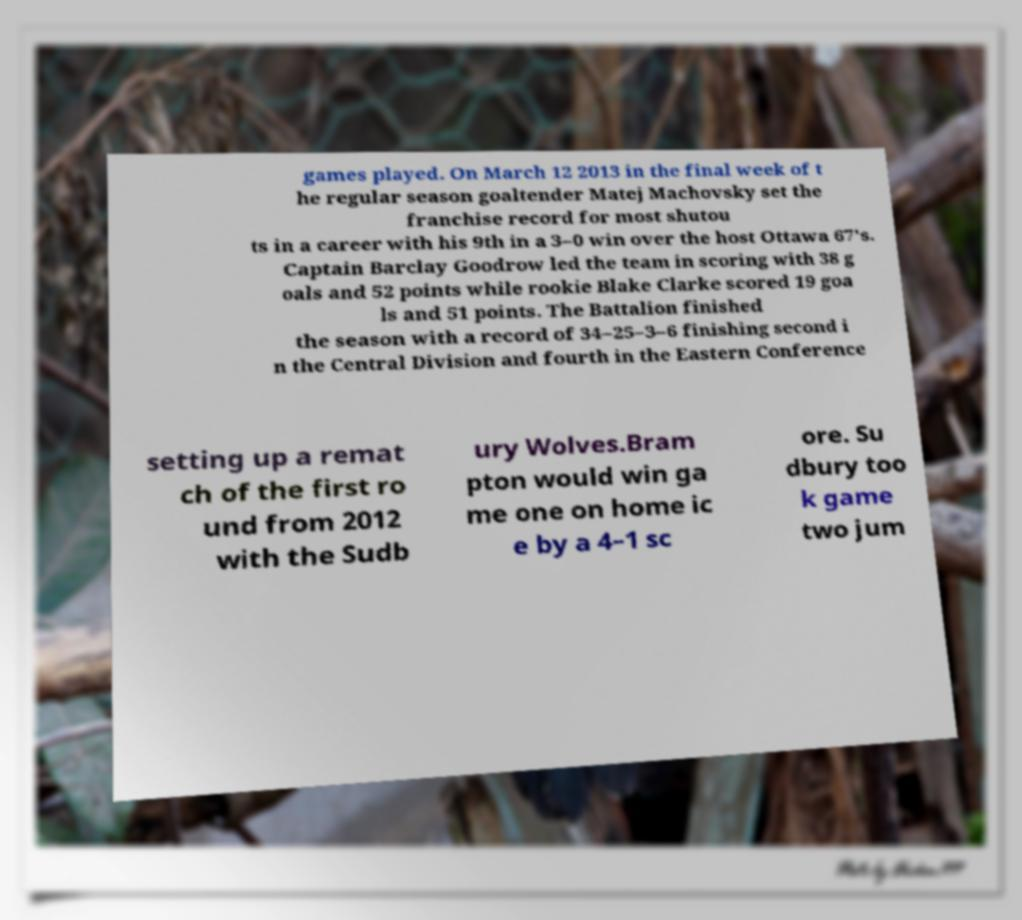Please identify and transcribe the text found in this image. games played. On March 12 2013 in the final week of t he regular season goaltender Matej Machovsky set the franchise record for most shutou ts in a career with his 9th in a 3–0 win over the host Ottawa 67's. Captain Barclay Goodrow led the team in scoring with 38 g oals and 52 points while rookie Blake Clarke scored 19 goa ls and 51 points. The Battalion finished the season with a record of 34–25–3–6 finishing second i n the Central Division and fourth in the Eastern Conference setting up a remat ch of the first ro und from 2012 with the Sudb ury Wolves.Bram pton would win ga me one on home ic e by a 4–1 sc ore. Su dbury too k game two jum 